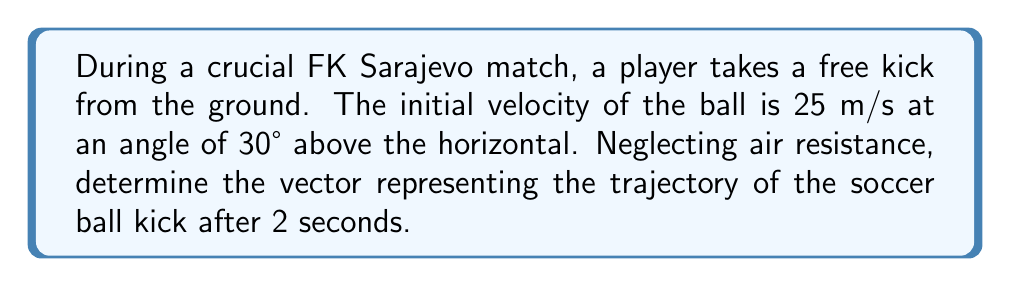Show me your answer to this math problem. Let's approach this step-by-step:

1) First, we need to decompose the initial velocity into its horizontal and vertical components:

   $v_x = v \cos\theta = 25 \cos(30°) = 21.65$ m/s
   $v_y = v \sin\theta = 25 \sin(30°) = 12.5$ m/s

2) Now, we can use the equations of motion for constant acceleration:

   $x(t) = v_x t$
   $y(t) = v_y t - \frac{1}{2}gt^2$

   Where $g = 9.8$ m/s² (acceleration due to gravity)

3) After 2 seconds:

   $x(2) = 21.65 \cdot 2 = 43.3$ m
   $y(2) = 12.5 \cdot 2 - \frac{1}{2} \cdot 9.8 \cdot 2^2 = 25 - 19.6 = 5.4$ m

4) The trajectory vector after 2 seconds is therefore:

   $$\vec{r} = \begin{pmatrix} 43.3 \\ 5.4 \end{pmatrix}$$

This vector represents the ball's position relative to its starting point after 2 seconds.
Answer: $$\vec{r} = \begin{pmatrix} 43.3 \\ 5.4 \end{pmatrix}$$ 